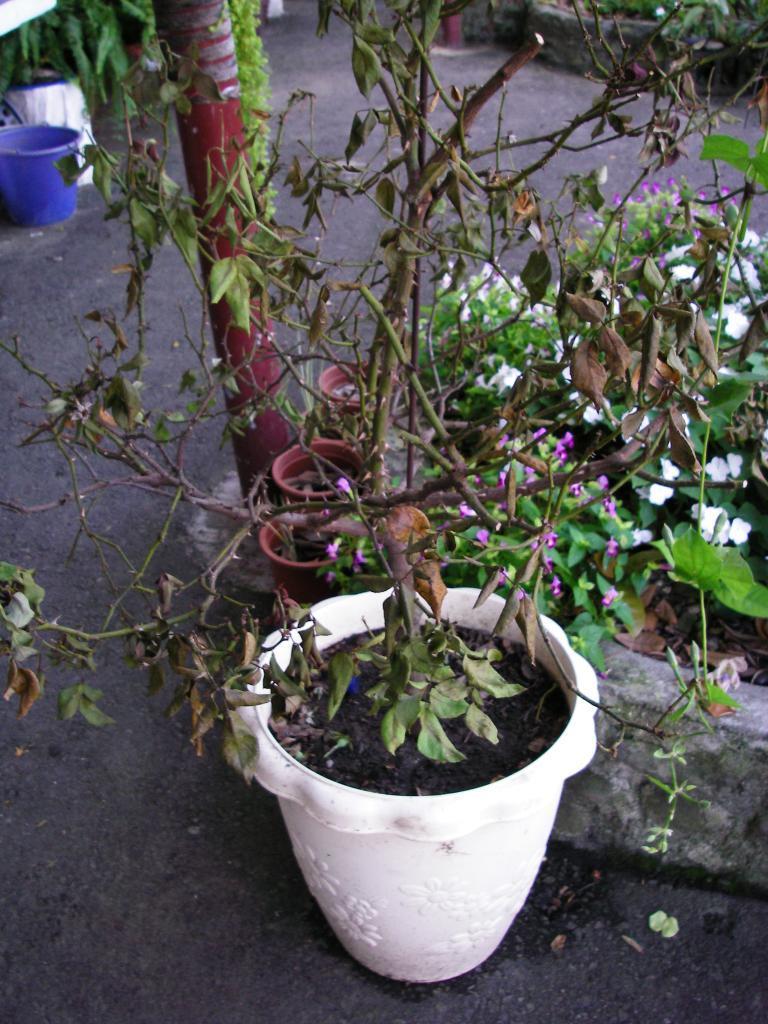How would you summarize this image in a sentence or two? In this image there are some plants with some flowers on the right side of this image , and there is a bucket on the top left corner of this image and there is a soil ground in the background. 